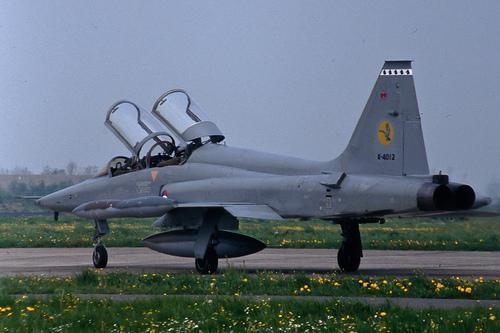How many windows are there?
Give a very brief answer. 2. 